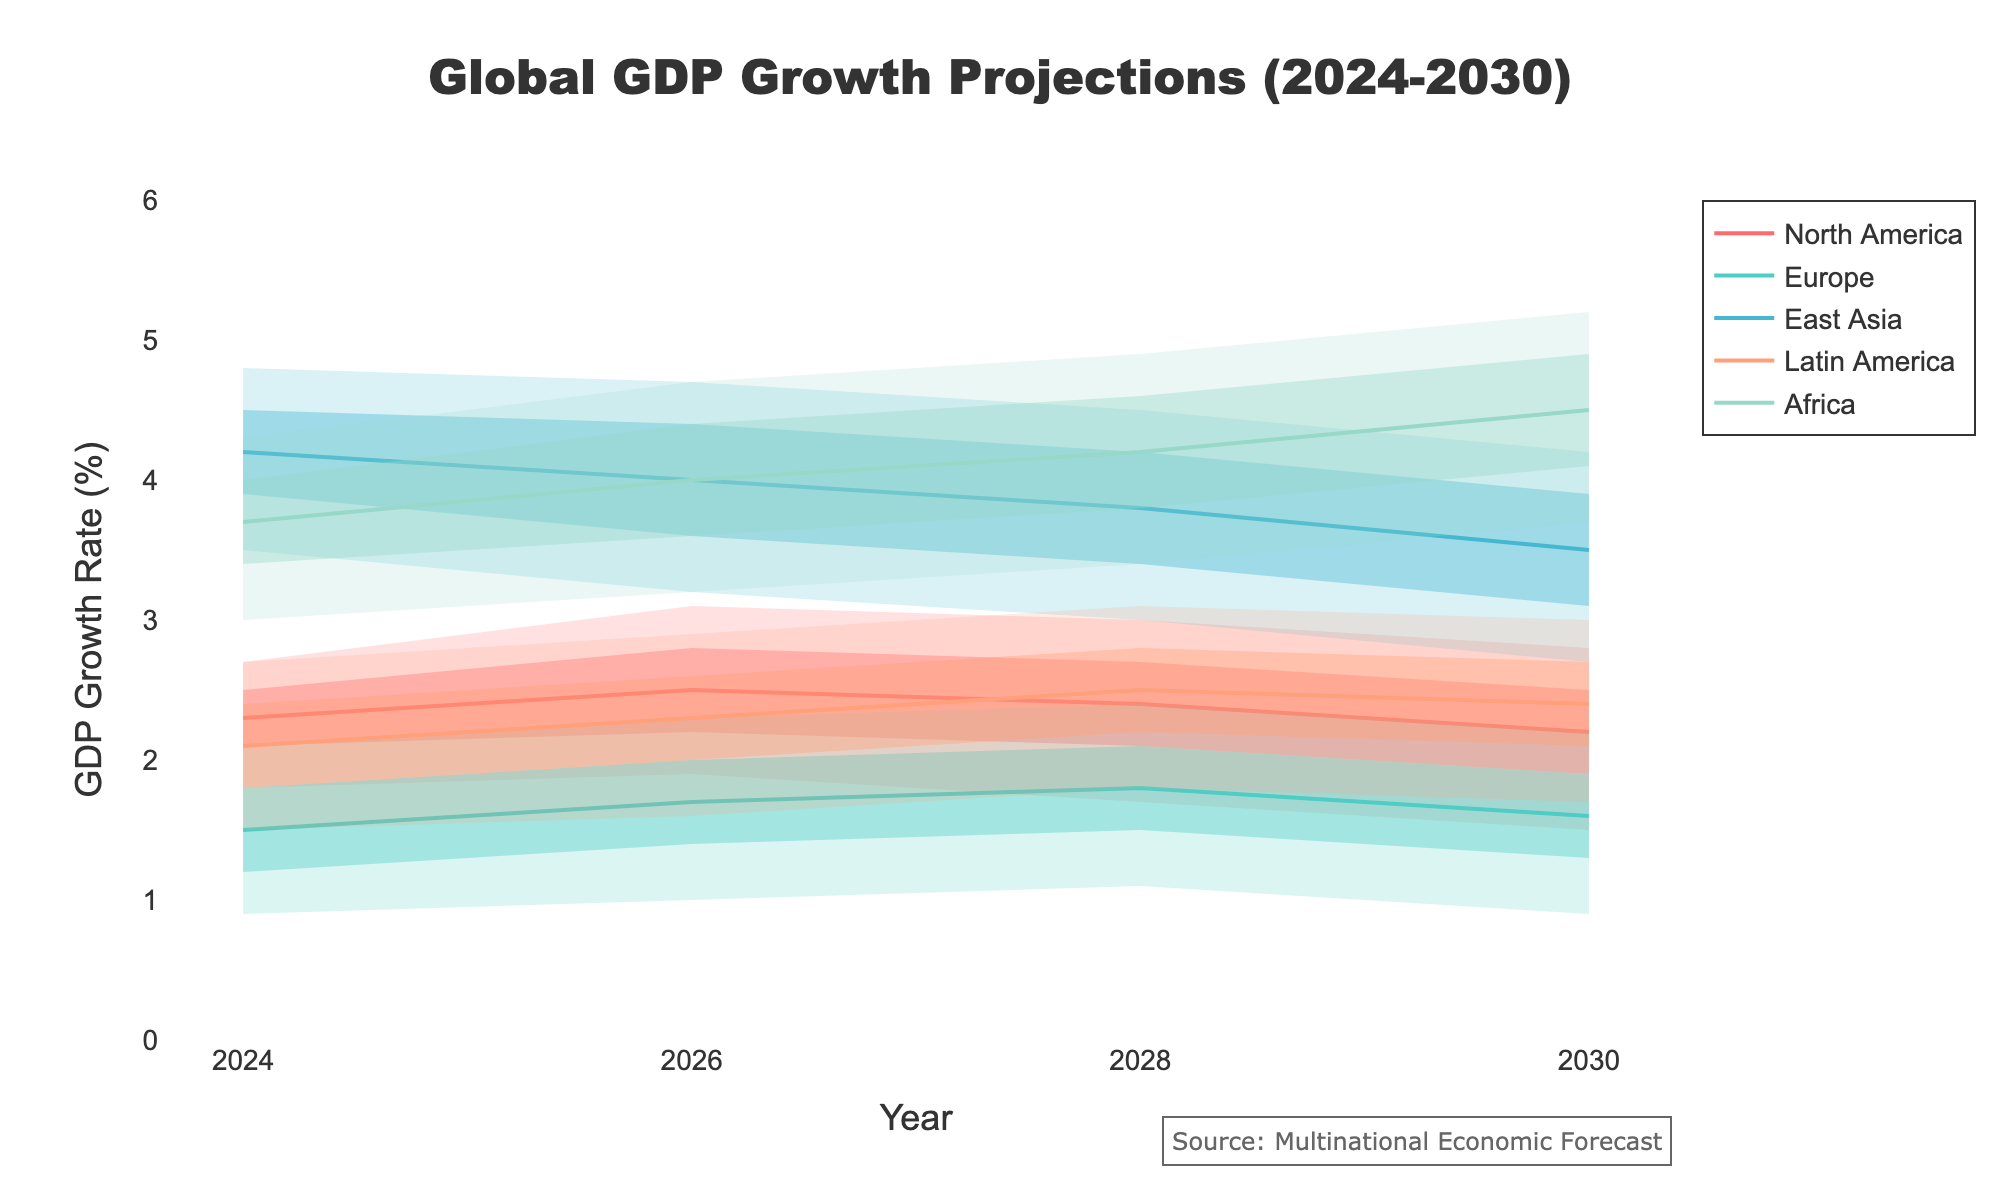what is the title of the figure? The title of the figure can be seen at the top of the visualization. It is usually concise and describes the main topic or data being presented.
Answer: Global GDP Growth Projections (2024-2030) How is the GDP growth rate of East Asia projected to change from 2024 to 2030? First, find the median rates for East Asia in 2024 and 2030. In 2024, it's 4.2%, and in 2030, it's 3.5%. Comparing these, note the decrease in the median growth rate.
Answer: It is projected to decrease from 4.2% to 3.5% Which region has the highest median GDP growth rate in 2028? Examine the median values for each region in 2028: North America (2.4%), Europe (1.8%), East Asia (3.8%), Latin America (2.5%), Africa (4.2%). The highest is Africa, with a median rate of 4.2%.
Answer: Africa In 2026, which regions have a median GDP growth rate higher than 2.2%? Compare the median GDP growth rates for all regions in 2026: North America (2.5%), Europe (1.7%), East Asia (4.0%), Latin America (2.3%), Africa (4.0%). The regions higher than 2.2% are North America, East Asia, Latin America, and Africa.
Answer: North America, East Asia, Latin America, Africa What is the range between the lower 10th and upper 90th percentiles for Europe in 2024? Subtract the lower 10th percentile value (0.9%) from the upper 90th percentile value (2.1%) for Europe in 2024. The difference is 2.1% - 0.9% = 1.2%.
Answer: 1.2% Which region shows the greatest uncertainty in GDP growth projections in 2030? The region with the greatest uncertainty will have the widest range between the lower 10th percentile and upper 90th percentile in 2030. Compare ranges: North America (2.8% - 1.5% = 1.3%), Europe (2.2% - 0.9% = 1.3%), East Asia (4.2% - 2.7% = 1.5%), Latin America (3.0% - 1.7% = 1.3%), Africa (5.2% - 3.7% = 1.5%). Both East Asia and Africa have the greatest range of 1.5%.
Answer: East Asia, Africa How does the median GDP growth rate for Latin America in 2028 compare to 2026? Identify the median growth rate in 2028 (2.5%) and in 2026 (2.3%). Compare the two values to see if there is an increase or decrease.
Answer: It increases from 2.3% to 2.5% Which region has the smallest expected growth variation (10th to 90th percentile) in 2024? Calculate the ranges: North America (2.7% - 1.8% = 0.9%), Europe (2.1% - 0.9% = 1.2%), East Asia (4.8% - 3.5% = 1.3%), Latin America (2.7% - 1.5% = 1.2%), Africa (4.3% - 3.0% = 1.3%). North America has the smallest range of 0.9%.
Answer: North America 